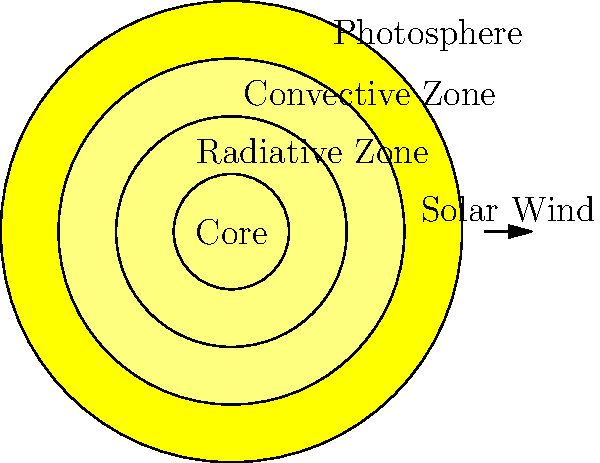As a UC Berkeley graduate with a critical eye, analyze the Sun's structure. Which layer, contrary to popular belief, is responsible for the majority of the Sun's mass, and what percentage does it constitute? Let's break this down step-by-step:

1. The Sun's structure consists of several layers: the core, radiative zone, convective zone, photosphere, chromosphere, and corona.

2. Many people might assume that the outer layers, being larger in volume, contain most of the Sun's mass. However, this is not the case.

3. The core, despite being the smallest layer visually, is incredibly dense. It's where nuclear fusion occurs, converting hydrogen into helium.

4. The core's density is about 150 g/cm³, compared to the outer layers which have densities closer to that of water (1 g/cm³) or even less.

5. Due to this extreme density, the core contains approximately 33% of the Sun's mass, despite occupying only about 1.5% of its volume.

6. The radiative zone, surrounding the core, contains about 48% of the Sun's mass.

7. Together, the core and radiative zone make up about 81% of the Sun's mass, despite occupying only about 25% of its volume.

8. Therefore, contrary to what many might expect, it's the core that contains the majority of the Sun's mass as a single layer.

This understanding challenges the intuitive notion that larger volumes contain more mass, highlighting the importance of density in astronomical bodies.
Answer: The core, containing approximately 33% of the Sun's mass. 